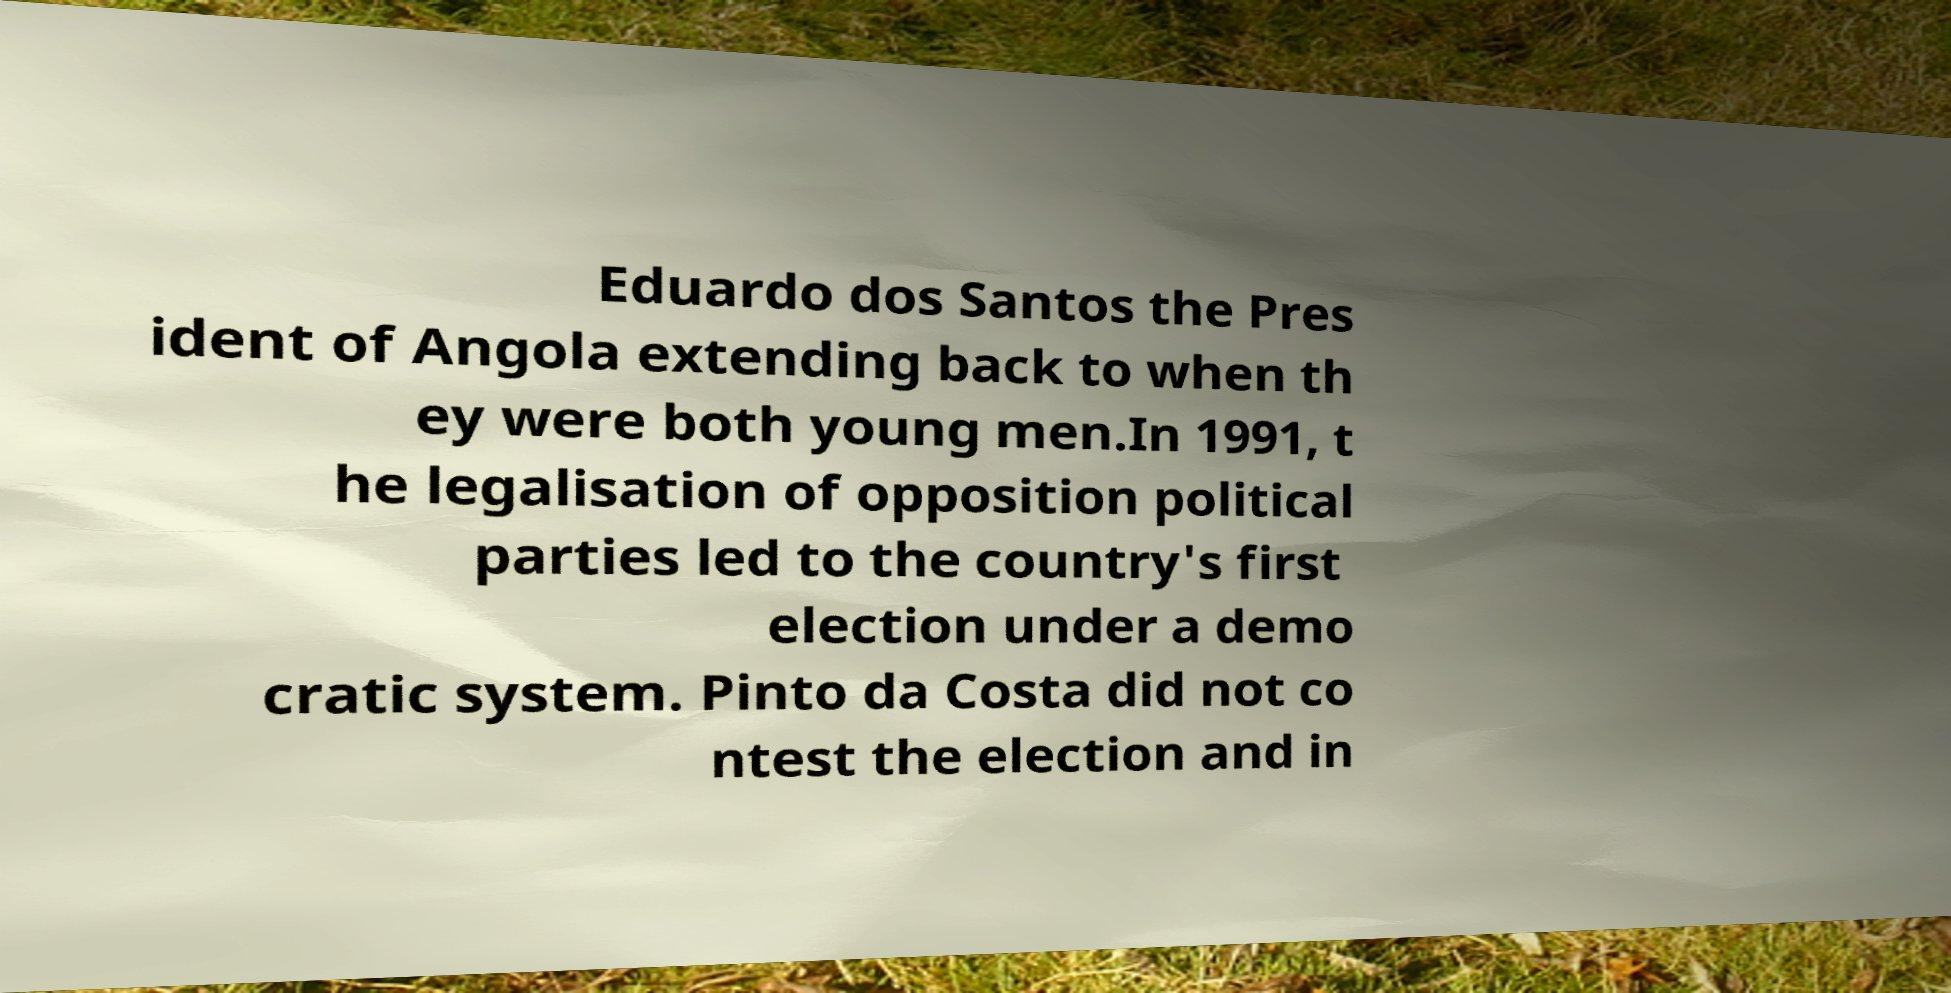Please identify and transcribe the text found in this image. Eduardo dos Santos the Pres ident of Angola extending back to when th ey were both young men.In 1991, t he legalisation of opposition political parties led to the country's first election under a demo cratic system. Pinto da Costa did not co ntest the election and in 